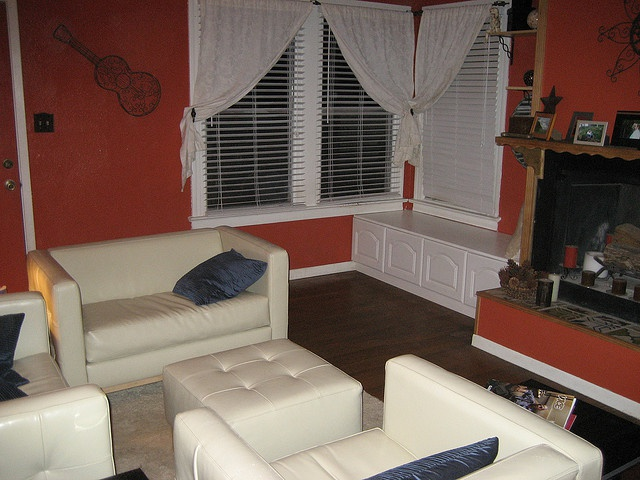Describe the objects in this image and their specific colors. I can see couch in black, darkgray, and gray tones, chair in black, beige, lightgray, darkgray, and tan tones, couch in black, darkgray, beige, and lightgray tones, and book in black and gray tones in this image. 